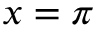Convert formula to latex. <formula><loc_0><loc_0><loc_500><loc_500>x = \pi</formula> 